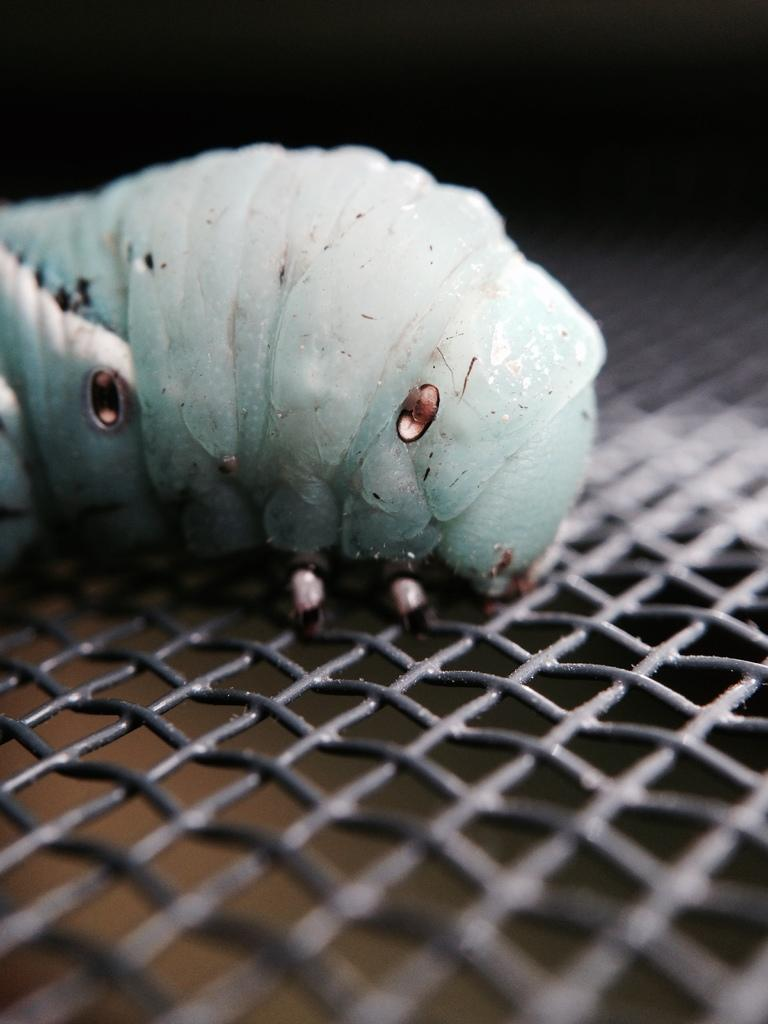What is the main subject of the image? The main subject of the image is a horn worm. Where is the horn worm located in the image? The horn worm is on a mesh. What type of border is visible around the horn worm in the image? There is no border visible around the horn worm in the image. 